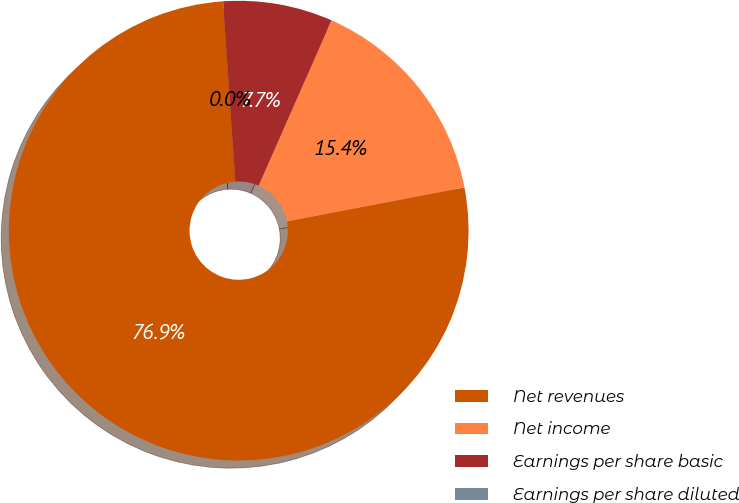Convert chart to OTSL. <chart><loc_0><loc_0><loc_500><loc_500><pie_chart><fcel>Net revenues<fcel>Net income<fcel>Earnings per share basic<fcel>Earnings per share diluted<nl><fcel>76.92%<fcel>15.38%<fcel>7.69%<fcel>0.0%<nl></chart> 